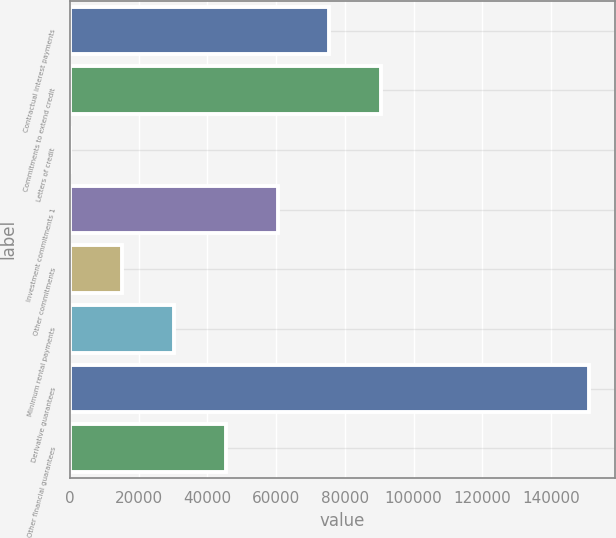Convert chart. <chart><loc_0><loc_0><loc_500><loc_500><bar_chart><fcel>Contractual interest payments<fcel>Commitments to extend credit<fcel>Letters of credit<fcel>Investment commitments 1<fcel>Other commitments<fcel>Minimum rental payments<fcel>Derivative guarantees<fcel>Other financial guarantees<nl><fcel>75501.5<fcel>90599<fcel>14<fcel>60404<fcel>15111.5<fcel>30209<fcel>150989<fcel>45306.5<nl></chart> 